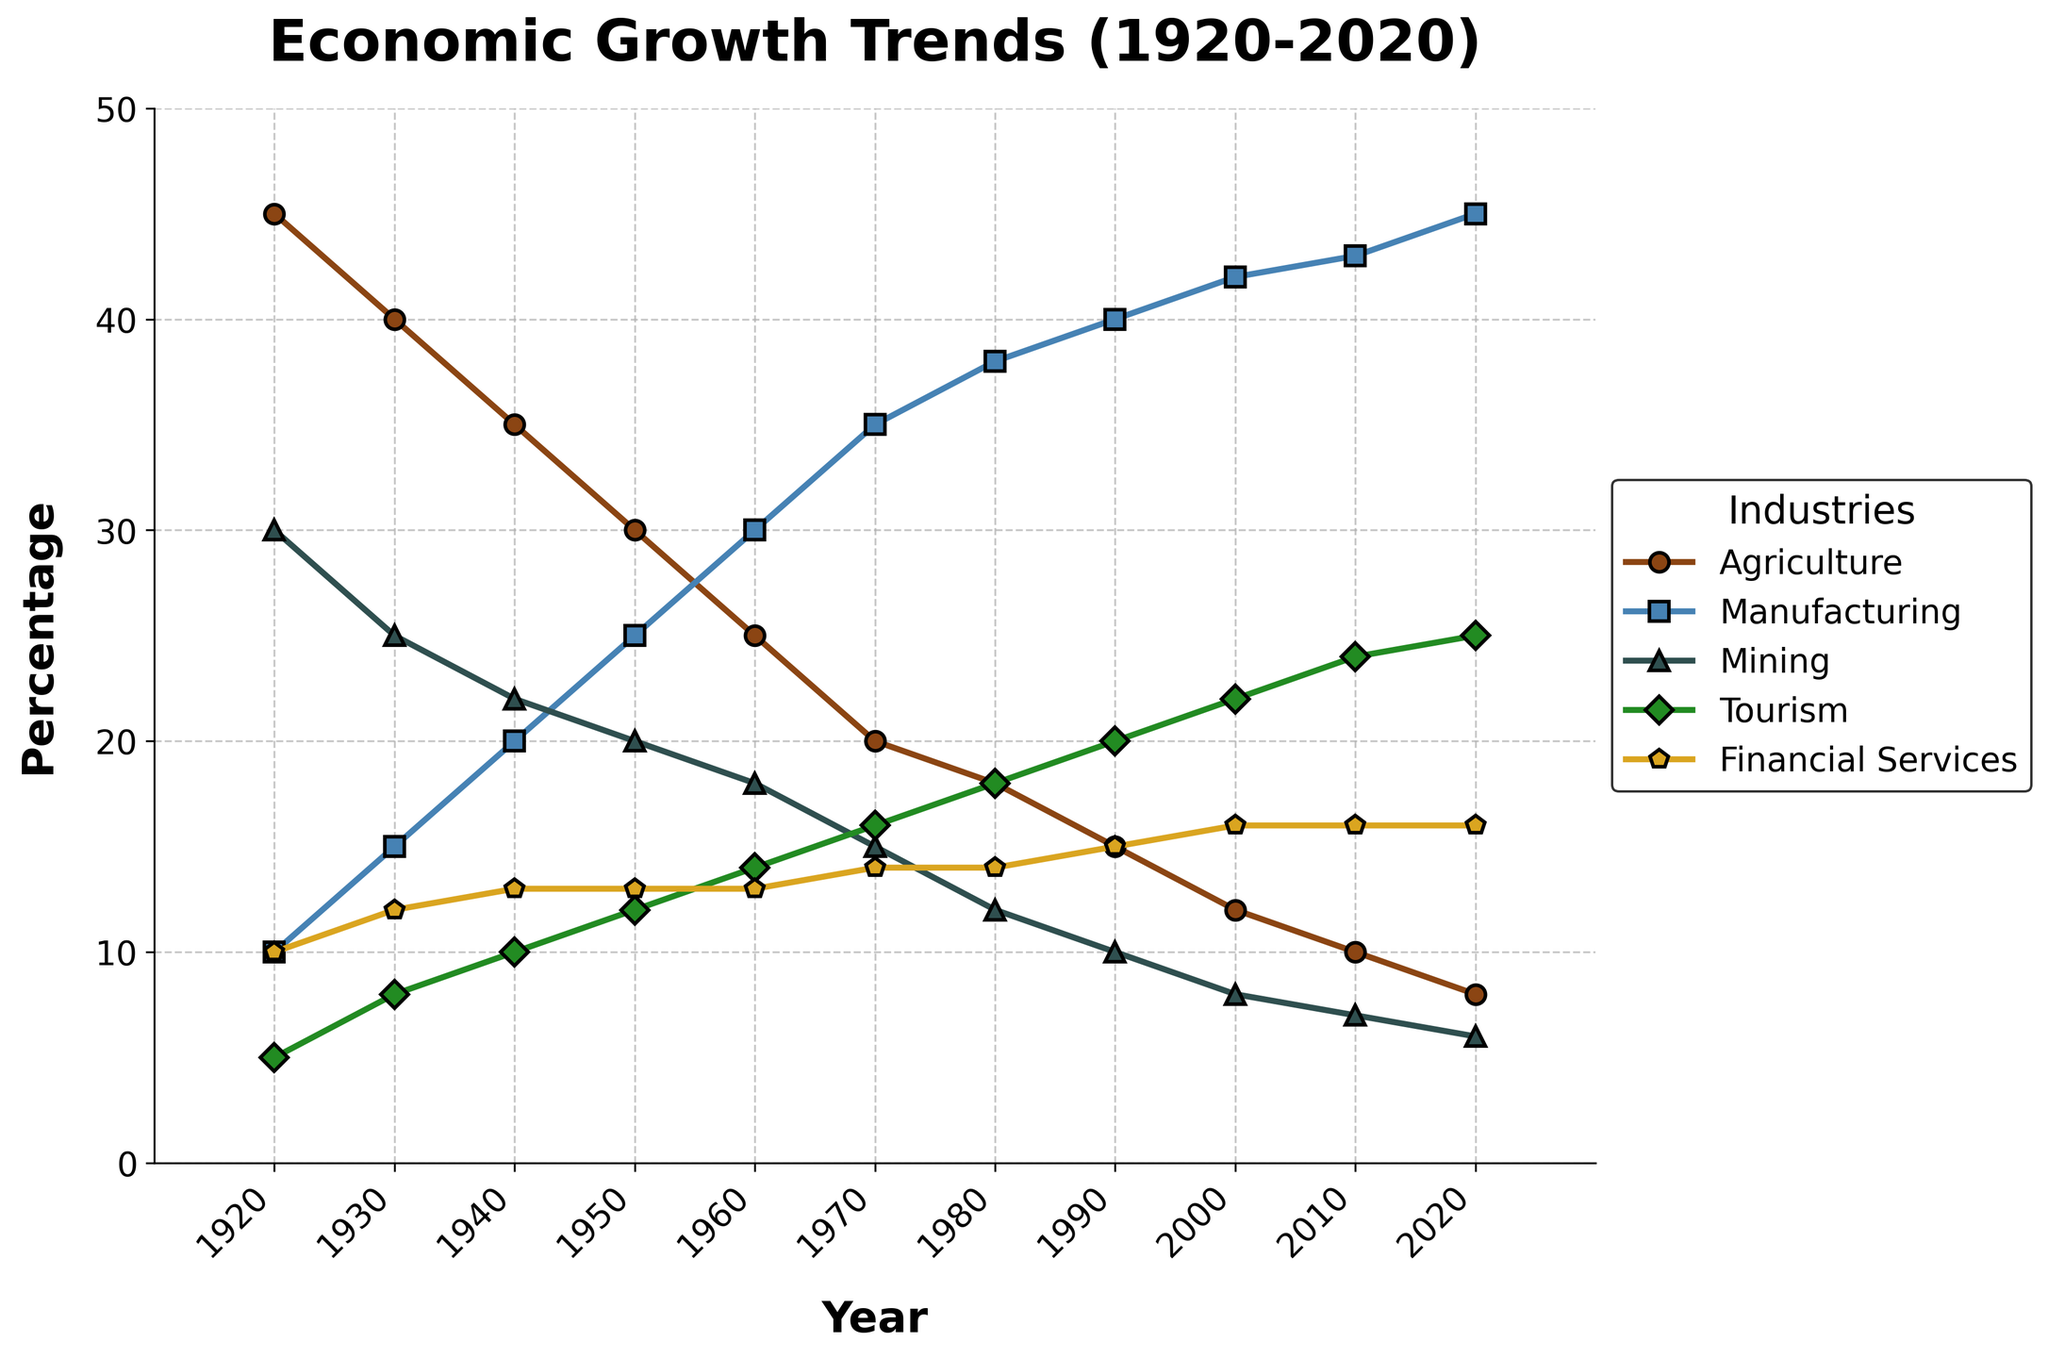Which industry showed the most significant decline from 1920 to 2020? The figure shows that the percentage of Agriculture decreased from 45% in 1920 to 8% in 2020. Comparing this with other industries, Agriculture had the largest decline.
Answer: Agriculture Compare the trends of Manufacturing and Mining between 1950 and 2020. Which one grew and which one shrank? From 1950 to 2020, Manufacturing grew from 25% to 45%. Conversely, Mining shrank from 20% to 6%. This indicates that Manufacturing experienced growth, while Mining declined.
Answer: Manufacturing grew, Mining shrank What decades did Tourism surpass Agriculture in percentage? Observing the trend lines, Tourism first surpassed Agriculture in the 1990s and continued to stay above Agriculture in the subsequent years.
Answer: 1990s onwards In which decade did Financial Services see the first increase from its initial value in 1920? Financial Services initially had a percentage of 10% in 1920 and saw an increase to 12% by 1930. Therefore, the first increase occurred in the 1930s.
Answer: 1930s How did Agriculture and Manufacturing compare in 1920 and 2020? In 1920, Agriculture was at 45%, while Manufacturing was at 10%. In 2020, Agriculture dropped to 8%, and Manufacturing increased to 45%. Initially, Agriculture surpassed Manufacturing, but the trend reversed by 2020.
Answer: Agriculture higher in 1920, Manufacturing higher in 2020 Calculate the average percentage value for Tourism over the century. Adding the percentages of Tourism from 1920 to 2020: (5 + 8 + 10 + 12 + 14 + 16 + 18 + 20 + 22 + 24 + 25) = 174. The average is 174/11 ≈ 15.82%.
Answer: ~15.82% Which industry remained the most stable in terms of percentage over the century? Financial Services started at 10% in 1920 and rose to 16% by 2020. This shows a relatively stable trend without significant fluctuations compared to other industries.
Answer: Financial Services What was the approximate change in the percentage of Manufacturing from 1970 to 2020? Manufacturing rose from 35% in 1970 to 45% in 2020. The change in percentage is 45% - 35% = 10%.
Answer: 10% Identify the year in which Mining had a major reduction and by how much compared to its previous value? Mining showed a significant drop from 38% in 1980 to 15% in 1970, marking a reduction of 38% - 15% = 23%.
Answer: 1970, 23% reduction 